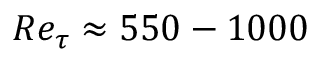Convert formula to latex. <formula><loc_0><loc_0><loc_500><loc_500>R e _ { \tau } \approx 5 5 0 - 1 0 0 0</formula> 